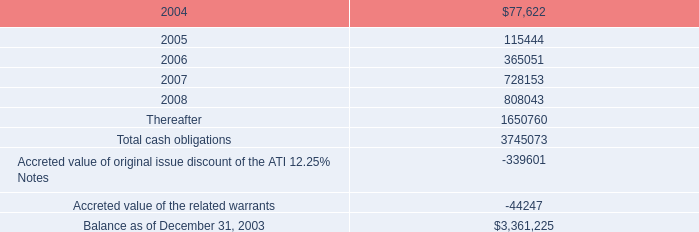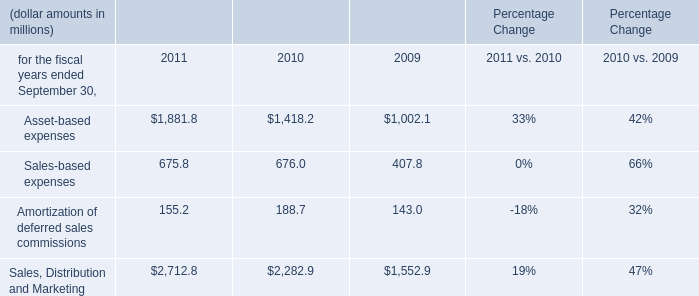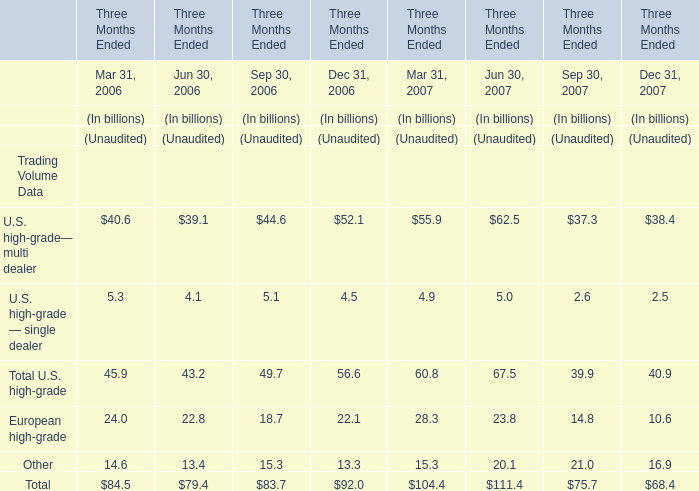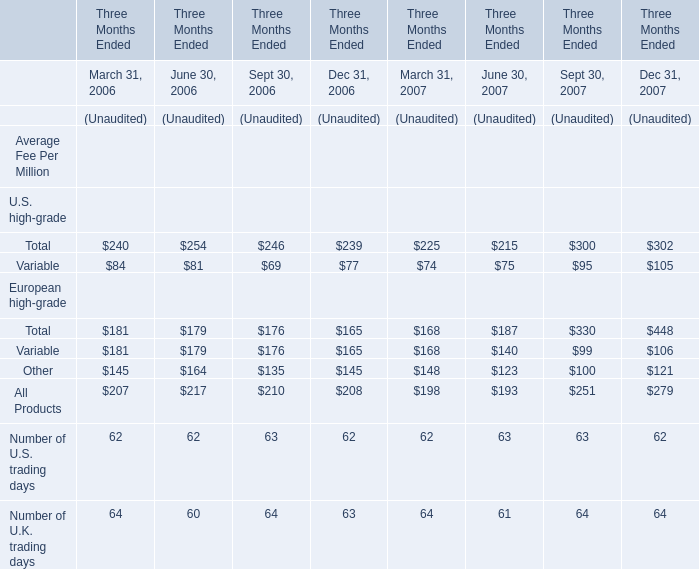For Section Jun 30,the year where Total Trading Volume is less,if unaudited,what is the value of Trading Volume of Other,if unaudited? (in billion) 
Answer: 13.4. 